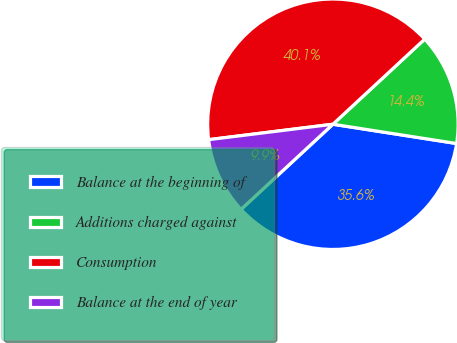Convert chart to OTSL. <chart><loc_0><loc_0><loc_500><loc_500><pie_chart><fcel>Balance at the beginning of<fcel>Additions charged against<fcel>Consumption<fcel>Balance at the end of year<nl><fcel>35.64%<fcel>14.36%<fcel>40.07%<fcel>9.93%<nl></chart> 